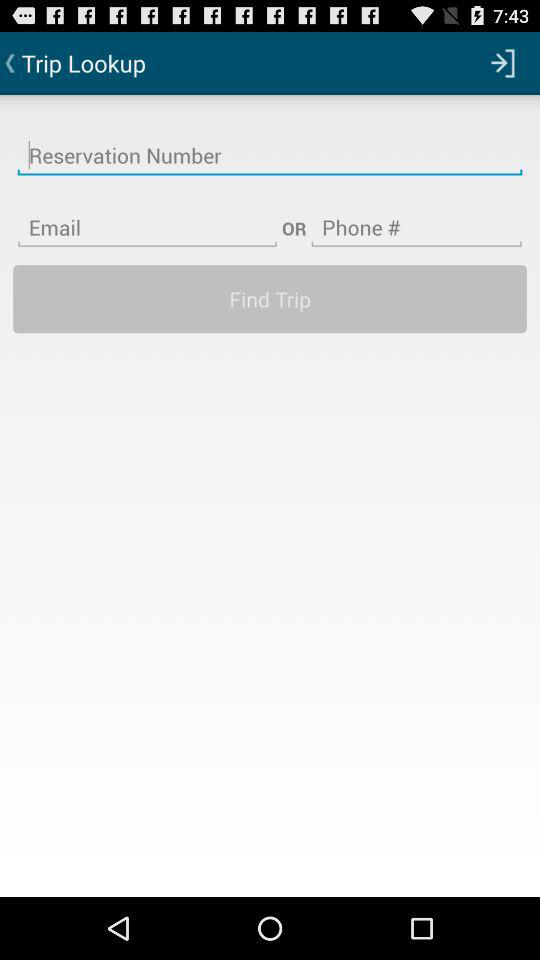How many text inputs are there for the user to enter information?
Answer the question using a single word or phrase. 3 